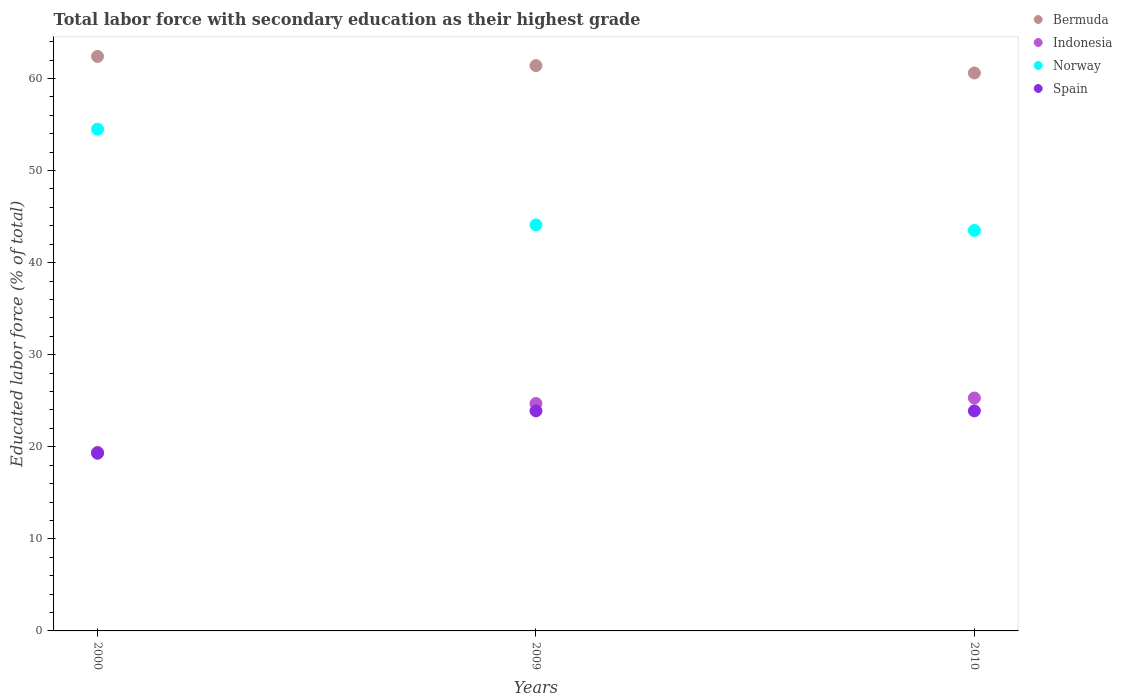Is the number of dotlines equal to the number of legend labels?
Ensure brevity in your answer.  Yes. What is the percentage of total labor force with primary education in Bermuda in 2010?
Provide a short and direct response. 60.6. Across all years, what is the maximum percentage of total labor force with primary education in Norway?
Provide a succinct answer. 54.5. Across all years, what is the minimum percentage of total labor force with primary education in Norway?
Provide a succinct answer. 43.5. In which year was the percentage of total labor force with primary education in Spain maximum?
Your answer should be compact. 2009. What is the total percentage of total labor force with primary education in Spain in the graph?
Give a very brief answer. 67.1. What is the difference between the percentage of total labor force with primary education in Bermuda in 2000 and that in 2010?
Give a very brief answer. 1.8. What is the difference between the percentage of total labor force with primary education in Bermuda in 2009 and the percentage of total labor force with primary education in Indonesia in 2010?
Make the answer very short. 36.1. What is the average percentage of total labor force with primary education in Norway per year?
Your answer should be compact. 47.37. In the year 2000, what is the difference between the percentage of total labor force with primary education in Norway and percentage of total labor force with primary education in Spain?
Offer a terse response. 35.2. In how many years, is the percentage of total labor force with primary education in Norway greater than 14 %?
Your answer should be compact. 3. What is the ratio of the percentage of total labor force with primary education in Norway in 2000 to that in 2009?
Offer a terse response. 1.24. Is the percentage of total labor force with primary education in Norway in 2009 less than that in 2010?
Provide a succinct answer. No. What is the difference between the highest and the second highest percentage of total labor force with primary education in Indonesia?
Your response must be concise. 0.6. Is the sum of the percentage of total labor force with primary education in Norway in 2000 and 2009 greater than the maximum percentage of total labor force with primary education in Bermuda across all years?
Offer a terse response. Yes. Is it the case that in every year, the sum of the percentage of total labor force with primary education in Indonesia and percentage of total labor force with primary education in Bermuda  is greater than the sum of percentage of total labor force with primary education in Norway and percentage of total labor force with primary education in Spain?
Your answer should be compact. Yes. Is it the case that in every year, the sum of the percentage of total labor force with primary education in Norway and percentage of total labor force with primary education in Indonesia  is greater than the percentage of total labor force with primary education in Spain?
Make the answer very short. Yes. Are the values on the major ticks of Y-axis written in scientific E-notation?
Offer a terse response. No. Does the graph contain any zero values?
Ensure brevity in your answer.  No. Where does the legend appear in the graph?
Your answer should be compact. Top right. What is the title of the graph?
Your answer should be very brief. Total labor force with secondary education as their highest grade. Does "Qatar" appear as one of the legend labels in the graph?
Make the answer very short. No. What is the label or title of the X-axis?
Keep it short and to the point. Years. What is the label or title of the Y-axis?
Offer a very short reply. Educated labor force (% of total). What is the Educated labor force (% of total) of Bermuda in 2000?
Your response must be concise. 62.4. What is the Educated labor force (% of total) of Indonesia in 2000?
Offer a terse response. 19.4. What is the Educated labor force (% of total) of Norway in 2000?
Your answer should be compact. 54.5. What is the Educated labor force (% of total) of Spain in 2000?
Make the answer very short. 19.3. What is the Educated labor force (% of total) in Bermuda in 2009?
Your answer should be compact. 61.4. What is the Educated labor force (% of total) in Indonesia in 2009?
Offer a terse response. 24.7. What is the Educated labor force (% of total) of Norway in 2009?
Your response must be concise. 44.1. What is the Educated labor force (% of total) in Spain in 2009?
Your answer should be compact. 23.9. What is the Educated labor force (% of total) of Bermuda in 2010?
Give a very brief answer. 60.6. What is the Educated labor force (% of total) of Indonesia in 2010?
Make the answer very short. 25.3. What is the Educated labor force (% of total) in Norway in 2010?
Provide a short and direct response. 43.5. What is the Educated labor force (% of total) in Spain in 2010?
Your answer should be very brief. 23.9. Across all years, what is the maximum Educated labor force (% of total) of Bermuda?
Your answer should be very brief. 62.4. Across all years, what is the maximum Educated labor force (% of total) in Indonesia?
Offer a terse response. 25.3. Across all years, what is the maximum Educated labor force (% of total) of Norway?
Your response must be concise. 54.5. Across all years, what is the maximum Educated labor force (% of total) in Spain?
Your answer should be very brief. 23.9. Across all years, what is the minimum Educated labor force (% of total) in Bermuda?
Offer a terse response. 60.6. Across all years, what is the minimum Educated labor force (% of total) of Indonesia?
Your answer should be compact. 19.4. Across all years, what is the minimum Educated labor force (% of total) in Norway?
Provide a succinct answer. 43.5. Across all years, what is the minimum Educated labor force (% of total) in Spain?
Offer a terse response. 19.3. What is the total Educated labor force (% of total) in Bermuda in the graph?
Your answer should be compact. 184.4. What is the total Educated labor force (% of total) of Indonesia in the graph?
Your answer should be very brief. 69.4. What is the total Educated labor force (% of total) of Norway in the graph?
Provide a succinct answer. 142.1. What is the total Educated labor force (% of total) of Spain in the graph?
Make the answer very short. 67.1. What is the difference between the Educated labor force (% of total) in Indonesia in 2000 and that in 2009?
Keep it short and to the point. -5.3. What is the difference between the Educated labor force (% of total) in Bermuda in 2000 and that in 2010?
Provide a succinct answer. 1.8. What is the difference between the Educated labor force (% of total) in Indonesia in 2000 and that in 2010?
Ensure brevity in your answer.  -5.9. What is the difference between the Educated labor force (% of total) in Bermuda in 2009 and that in 2010?
Your answer should be compact. 0.8. What is the difference between the Educated labor force (% of total) in Indonesia in 2009 and that in 2010?
Make the answer very short. -0.6. What is the difference between the Educated labor force (% of total) of Spain in 2009 and that in 2010?
Your answer should be compact. 0. What is the difference between the Educated labor force (% of total) in Bermuda in 2000 and the Educated labor force (% of total) in Indonesia in 2009?
Provide a succinct answer. 37.7. What is the difference between the Educated labor force (% of total) in Bermuda in 2000 and the Educated labor force (% of total) in Spain in 2009?
Make the answer very short. 38.5. What is the difference between the Educated labor force (% of total) in Indonesia in 2000 and the Educated labor force (% of total) in Norway in 2009?
Your answer should be very brief. -24.7. What is the difference between the Educated labor force (% of total) of Norway in 2000 and the Educated labor force (% of total) of Spain in 2009?
Keep it short and to the point. 30.6. What is the difference between the Educated labor force (% of total) in Bermuda in 2000 and the Educated labor force (% of total) in Indonesia in 2010?
Provide a short and direct response. 37.1. What is the difference between the Educated labor force (% of total) in Bermuda in 2000 and the Educated labor force (% of total) in Norway in 2010?
Offer a very short reply. 18.9. What is the difference between the Educated labor force (% of total) in Bermuda in 2000 and the Educated labor force (% of total) in Spain in 2010?
Provide a succinct answer. 38.5. What is the difference between the Educated labor force (% of total) in Indonesia in 2000 and the Educated labor force (% of total) in Norway in 2010?
Offer a very short reply. -24.1. What is the difference between the Educated labor force (% of total) in Norway in 2000 and the Educated labor force (% of total) in Spain in 2010?
Your answer should be very brief. 30.6. What is the difference between the Educated labor force (% of total) of Bermuda in 2009 and the Educated labor force (% of total) of Indonesia in 2010?
Ensure brevity in your answer.  36.1. What is the difference between the Educated labor force (% of total) in Bermuda in 2009 and the Educated labor force (% of total) in Norway in 2010?
Your response must be concise. 17.9. What is the difference between the Educated labor force (% of total) in Bermuda in 2009 and the Educated labor force (% of total) in Spain in 2010?
Offer a terse response. 37.5. What is the difference between the Educated labor force (% of total) in Indonesia in 2009 and the Educated labor force (% of total) in Norway in 2010?
Offer a very short reply. -18.8. What is the difference between the Educated labor force (% of total) in Indonesia in 2009 and the Educated labor force (% of total) in Spain in 2010?
Offer a terse response. 0.8. What is the difference between the Educated labor force (% of total) in Norway in 2009 and the Educated labor force (% of total) in Spain in 2010?
Provide a short and direct response. 20.2. What is the average Educated labor force (% of total) of Bermuda per year?
Your answer should be very brief. 61.47. What is the average Educated labor force (% of total) in Indonesia per year?
Provide a short and direct response. 23.13. What is the average Educated labor force (% of total) of Norway per year?
Offer a terse response. 47.37. What is the average Educated labor force (% of total) of Spain per year?
Offer a very short reply. 22.37. In the year 2000, what is the difference between the Educated labor force (% of total) in Bermuda and Educated labor force (% of total) in Norway?
Provide a short and direct response. 7.9. In the year 2000, what is the difference between the Educated labor force (% of total) in Bermuda and Educated labor force (% of total) in Spain?
Ensure brevity in your answer.  43.1. In the year 2000, what is the difference between the Educated labor force (% of total) in Indonesia and Educated labor force (% of total) in Norway?
Ensure brevity in your answer.  -35.1. In the year 2000, what is the difference between the Educated labor force (% of total) of Indonesia and Educated labor force (% of total) of Spain?
Your answer should be very brief. 0.1. In the year 2000, what is the difference between the Educated labor force (% of total) of Norway and Educated labor force (% of total) of Spain?
Offer a very short reply. 35.2. In the year 2009, what is the difference between the Educated labor force (% of total) in Bermuda and Educated labor force (% of total) in Indonesia?
Provide a succinct answer. 36.7. In the year 2009, what is the difference between the Educated labor force (% of total) of Bermuda and Educated labor force (% of total) of Spain?
Your response must be concise. 37.5. In the year 2009, what is the difference between the Educated labor force (% of total) of Indonesia and Educated labor force (% of total) of Norway?
Provide a succinct answer. -19.4. In the year 2009, what is the difference between the Educated labor force (% of total) in Indonesia and Educated labor force (% of total) in Spain?
Provide a short and direct response. 0.8. In the year 2009, what is the difference between the Educated labor force (% of total) in Norway and Educated labor force (% of total) in Spain?
Ensure brevity in your answer.  20.2. In the year 2010, what is the difference between the Educated labor force (% of total) of Bermuda and Educated labor force (% of total) of Indonesia?
Give a very brief answer. 35.3. In the year 2010, what is the difference between the Educated labor force (% of total) of Bermuda and Educated labor force (% of total) of Spain?
Your answer should be very brief. 36.7. In the year 2010, what is the difference between the Educated labor force (% of total) in Indonesia and Educated labor force (% of total) in Norway?
Ensure brevity in your answer.  -18.2. In the year 2010, what is the difference between the Educated labor force (% of total) in Indonesia and Educated labor force (% of total) in Spain?
Your answer should be very brief. 1.4. In the year 2010, what is the difference between the Educated labor force (% of total) of Norway and Educated labor force (% of total) of Spain?
Your answer should be very brief. 19.6. What is the ratio of the Educated labor force (% of total) in Bermuda in 2000 to that in 2009?
Ensure brevity in your answer.  1.02. What is the ratio of the Educated labor force (% of total) of Indonesia in 2000 to that in 2009?
Make the answer very short. 0.79. What is the ratio of the Educated labor force (% of total) of Norway in 2000 to that in 2009?
Make the answer very short. 1.24. What is the ratio of the Educated labor force (% of total) in Spain in 2000 to that in 2009?
Your answer should be very brief. 0.81. What is the ratio of the Educated labor force (% of total) in Bermuda in 2000 to that in 2010?
Provide a succinct answer. 1.03. What is the ratio of the Educated labor force (% of total) in Indonesia in 2000 to that in 2010?
Offer a terse response. 0.77. What is the ratio of the Educated labor force (% of total) in Norway in 2000 to that in 2010?
Offer a terse response. 1.25. What is the ratio of the Educated labor force (% of total) of Spain in 2000 to that in 2010?
Your response must be concise. 0.81. What is the ratio of the Educated labor force (% of total) in Bermuda in 2009 to that in 2010?
Offer a terse response. 1.01. What is the ratio of the Educated labor force (% of total) of Indonesia in 2009 to that in 2010?
Make the answer very short. 0.98. What is the ratio of the Educated labor force (% of total) in Norway in 2009 to that in 2010?
Your answer should be very brief. 1.01. What is the difference between the highest and the second highest Educated labor force (% of total) in Bermuda?
Make the answer very short. 1. What is the difference between the highest and the second highest Educated labor force (% of total) in Indonesia?
Make the answer very short. 0.6. What is the difference between the highest and the second highest Educated labor force (% of total) of Spain?
Offer a very short reply. 0. What is the difference between the highest and the lowest Educated labor force (% of total) of Bermuda?
Make the answer very short. 1.8. What is the difference between the highest and the lowest Educated labor force (% of total) of Norway?
Provide a succinct answer. 11. 